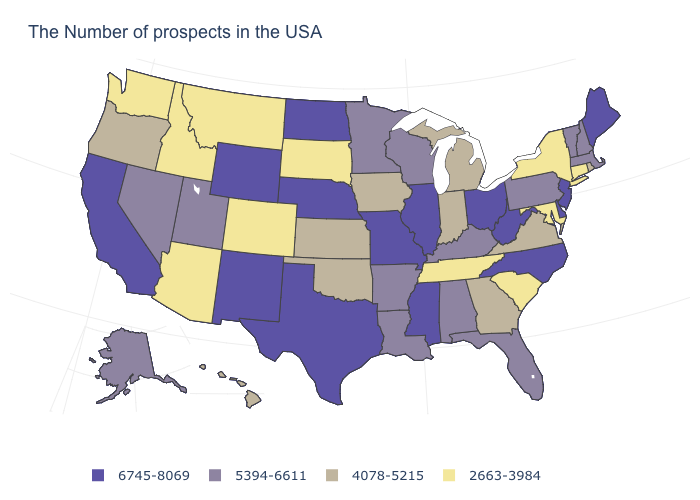Name the states that have a value in the range 2663-3984?
Answer briefly. Connecticut, New York, Maryland, South Carolina, Tennessee, South Dakota, Colorado, Montana, Arizona, Idaho, Washington. What is the value of New Hampshire?
Be succinct. 5394-6611. What is the highest value in the USA?
Give a very brief answer. 6745-8069. Name the states that have a value in the range 2663-3984?
Concise answer only. Connecticut, New York, Maryland, South Carolina, Tennessee, South Dakota, Colorado, Montana, Arizona, Idaho, Washington. Which states hav the highest value in the West?
Keep it brief. Wyoming, New Mexico, California. Name the states that have a value in the range 4078-5215?
Be succinct. Rhode Island, Virginia, Georgia, Michigan, Indiana, Iowa, Kansas, Oklahoma, Oregon, Hawaii. Name the states that have a value in the range 2663-3984?
Give a very brief answer. Connecticut, New York, Maryland, South Carolina, Tennessee, South Dakota, Colorado, Montana, Arizona, Idaho, Washington. Name the states that have a value in the range 2663-3984?
Answer briefly. Connecticut, New York, Maryland, South Carolina, Tennessee, South Dakota, Colorado, Montana, Arizona, Idaho, Washington. Does Mississippi have the lowest value in the USA?
Quick response, please. No. Among the states that border Nebraska , which have the highest value?
Give a very brief answer. Missouri, Wyoming. What is the value of Washington?
Answer briefly. 2663-3984. Does Connecticut have the highest value in the USA?
Concise answer only. No. Does West Virginia have the lowest value in the USA?
Answer briefly. No. Name the states that have a value in the range 2663-3984?
Keep it brief. Connecticut, New York, Maryland, South Carolina, Tennessee, South Dakota, Colorado, Montana, Arizona, Idaho, Washington. What is the value of Georgia?
Quick response, please. 4078-5215. 